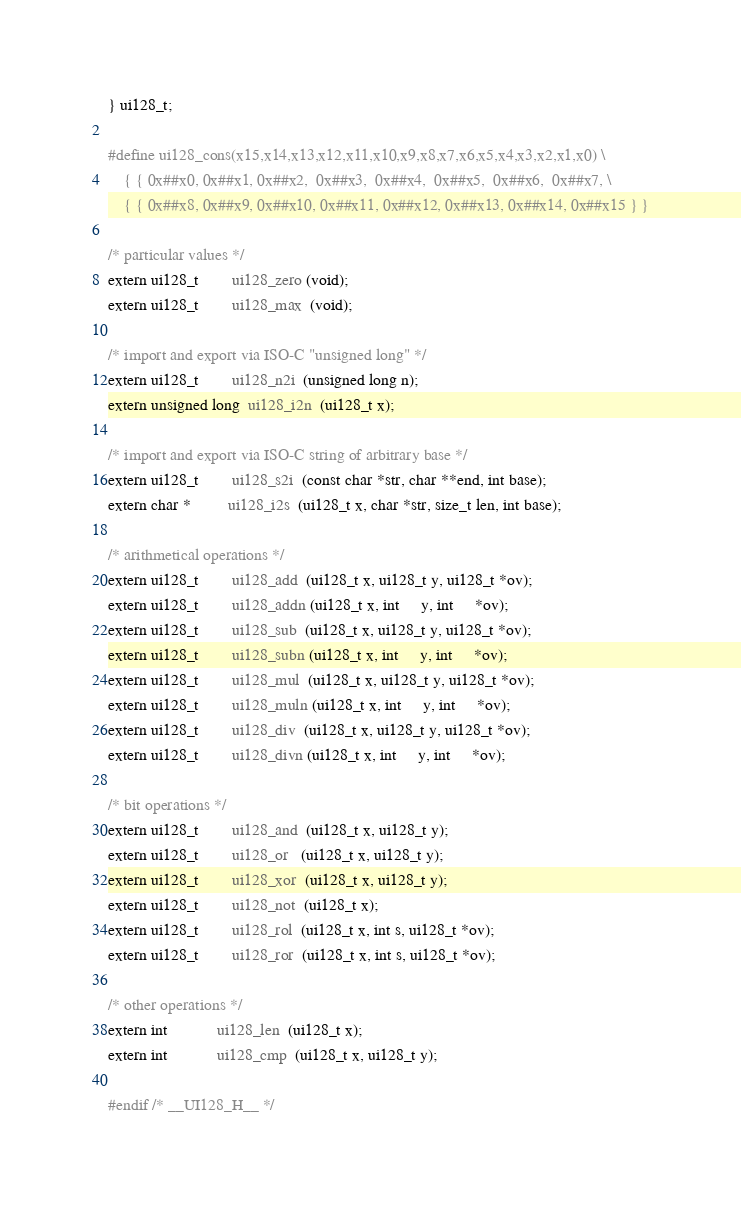Convert code to text. <code><loc_0><loc_0><loc_500><loc_500><_C_>} ui128_t;

#define ui128_cons(x15,x14,x13,x12,x11,x10,x9,x8,x7,x6,x5,x4,x3,x2,x1,x0) \
    { { 0x##x0, 0x##x1, 0x##x2,  0x##x3,  0x##x4,  0x##x5,  0x##x6,  0x##x7, \
    { { 0x##x8, 0x##x9, 0x##x10, 0x##x11, 0x##x12, 0x##x13, 0x##x14, 0x##x15 } }

/* particular values */
extern ui128_t        ui128_zero (void);
extern ui128_t        ui128_max  (void);

/* import and export via ISO-C "unsigned long" */
extern ui128_t        ui128_n2i  (unsigned long n);
extern unsigned long  ui128_i2n  (ui128_t x);

/* import and export via ISO-C string of arbitrary base */
extern ui128_t        ui128_s2i  (const char *str, char **end, int base);
extern char *         ui128_i2s  (ui128_t x, char *str, size_t len, int base);

/* arithmetical operations */
extern ui128_t        ui128_add  (ui128_t x, ui128_t y, ui128_t *ov);
extern ui128_t        ui128_addn (ui128_t x, int     y, int     *ov);
extern ui128_t        ui128_sub  (ui128_t x, ui128_t y, ui128_t *ov);
extern ui128_t        ui128_subn (ui128_t x, int     y, int     *ov);
extern ui128_t        ui128_mul  (ui128_t x, ui128_t y, ui128_t *ov);
extern ui128_t        ui128_muln (ui128_t x, int     y, int     *ov);
extern ui128_t        ui128_div  (ui128_t x, ui128_t y, ui128_t *ov);
extern ui128_t        ui128_divn (ui128_t x, int     y, int     *ov);

/* bit operations */
extern ui128_t        ui128_and  (ui128_t x, ui128_t y);
extern ui128_t        ui128_or   (ui128_t x, ui128_t y);
extern ui128_t        ui128_xor  (ui128_t x, ui128_t y);
extern ui128_t        ui128_not  (ui128_t x);
extern ui128_t        ui128_rol  (ui128_t x, int s, ui128_t *ov);
extern ui128_t        ui128_ror  (ui128_t x, int s, ui128_t *ov);

/* other operations */
extern int            ui128_len  (ui128_t x);
extern int            ui128_cmp  (ui128_t x, ui128_t y);

#endif /* __UI128_H__ */

</code> 